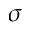Convert formula to latex. <formula><loc_0><loc_0><loc_500><loc_500>\sigma</formula> 